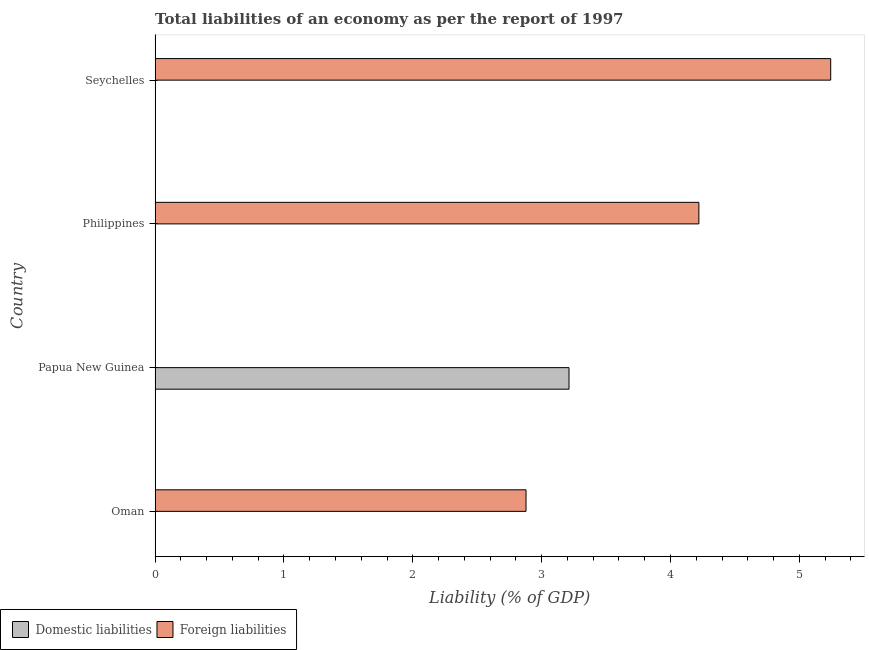Are the number of bars per tick equal to the number of legend labels?
Provide a succinct answer. No. Are the number of bars on each tick of the Y-axis equal?
Ensure brevity in your answer.  Yes. How many bars are there on the 3rd tick from the top?
Ensure brevity in your answer.  1. How many bars are there on the 1st tick from the bottom?
Give a very brief answer. 1. What is the label of the 3rd group of bars from the top?
Provide a short and direct response. Papua New Guinea. In how many cases, is the number of bars for a given country not equal to the number of legend labels?
Offer a terse response. 4. Across all countries, what is the maximum incurrence of domestic liabilities?
Provide a succinct answer. 3.21. Across all countries, what is the minimum incurrence of domestic liabilities?
Ensure brevity in your answer.  0. In which country was the incurrence of domestic liabilities maximum?
Give a very brief answer. Papua New Guinea. What is the total incurrence of foreign liabilities in the graph?
Your answer should be very brief. 12.34. What is the difference between the incurrence of foreign liabilities in Oman and that in Seychelles?
Your answer should be very brief. -2.36. What is the difference between the incurrence of foreign liabilities in Philippines and the incurrence of domestic liabilities in Seychelles?
Ensure brevity in your answer.  4.22. What is the average incurrence of domestic liabilities per country?
Provide a short and direct response. 0.8. What is the ratio of the incurrence of foreign liabilities in Oman to that in Seychelles?
Your answer should be compact. 0.55. Is the incurrence of foreign liabilities in Oman less than that in Philippines?
Offer a very short reply. Yes. What is the difference between the highest and the second highest incurrence of foreign liabilities?
Your response must be concise. 1.02. What is the difference between the highest and the lowest incurrence of foreign liabilities?
Keep it short and to the point. 5.24. In how many countries, is the incurrence of foreign liabilities greater than the average incurrence of foreign liabilities taken over all countries?
Ensure brevity in your answer.  2. Is the sum of the incurrence of foreign liabilities in Oman and Seychelles greater than the maximum incurrence of domestic liabilities across all countries?
Keep it short and to the point. Yes. How many countries are there in the graph?
Your response must be concise. 4. What is the difference between two consecutive major ticks on the X-axis?
Your response must be concise. 1. Does the graph contain any zero values?
Give a very brief answer. Yes. What is the title of the graph?
Keep it short and to the point. Total liabilities of an economy as per the report of 1997. Does "Register a business" appear as one of the legend labels in the graph?
Offer a very short reply. No. What is the label or title of the X-axis?
Your response must be concise. Liability (% of GDP). What is the label or title of the Y-axis?
Your answer should be compact. Country. What is the Liability (% of GDP) in Foreign liabilities in Oman?
Your answer should be compact. 2.88. What is the Liability (% of GDP) in Domestic liabilities in Papua New Guinea?
Your response must be concise. 3.21. What is the Liability (% of GDP) of Domestic liabilities in Philippines?
Offer a very short reply. 0. What is the Liability (% of GDP) of Foreign liabilities in Philippines?
Your response must be concise. 4.22. What is the Liability (% of GDP) of Foreign liabilities in Seychelles?
Make the answer very short. 5.24. Across all countries, what is the maximum Liability (% of GDP) of Domestic liabilities?
Make the answer very short. 3.21. Across all countries, what is the maximum Liability (% of GDP) of Foreign liabilities?
Your response must be concise. 5.24. Across all countries, what is the minimum Liability (% of GDP) of Foreign liabilities?
Keep it short and to the point. 0. What is the total Liability (% of GDP) of Domestic liabilities in the graph?
Keep it short and to the point. 3.21. What is the total Liability (% of GDP) in Foreign liabilities in the graph?
Your answer should be compact. 12.34. What is the difference between the Liability (% of GDP) in Foreign liabilities in Oman and that in Philippines?
Offer a terse response. -1.34. What is the difference between the Liability (% of GDP) in Foreign liabilities in Oman and that in Seychelles?
Keep it short and to the point. -2.36. What is the difference between the Liability (% of GDP) in Foreign liabilities in Philippines and that in Seychelles?
Your response must be concise. -1.02. What is the difference between the Liability (% of GDP) of Domestic liabilities in Papua New Guinea and the Liability (% of GDP) of Foreign liabilities in Philippines?
Provide a succinct answer. -1.01. What is the difference between the Liability (% of GDP) in Domestic liabilities in Papua New Guinea and the Liability (% of GDP) in Foreign liabilities in Seychelles?
Your answer should be compact. -2.03. What is the average Liability (% of GDP) of Domestic liabilities per country?
Give a very brief answer. 0.8. What is the average Liability (% of GDP) in Foreign liabilities per country?
Your answer should be very brief. 3.09. What is the ratio of the Liability (% of GDP) in Foreign liabilities in Oman to that in Philippines?
Give a very brief answer. 0.68. What is the ratio of the Liability (% of GDP) in Foreign liabilities in Oman to that in Seychelles?
Offer a very short reply. 0.55. What is the ratio of the Liability (% of GDP) in Foreign liabilities in Philippines to that in Seychelles?
Provide a short and direct response. 0.8. What is the difference between the highest and the lowest Liability (% of GDP) in Domestic liabilities?
Your answer should be compact. 3.21. What is the difference between the highest and the lowest Liability (% of GDP) of Foreign liabilities?
Your answer should be very brief. 5.24. 